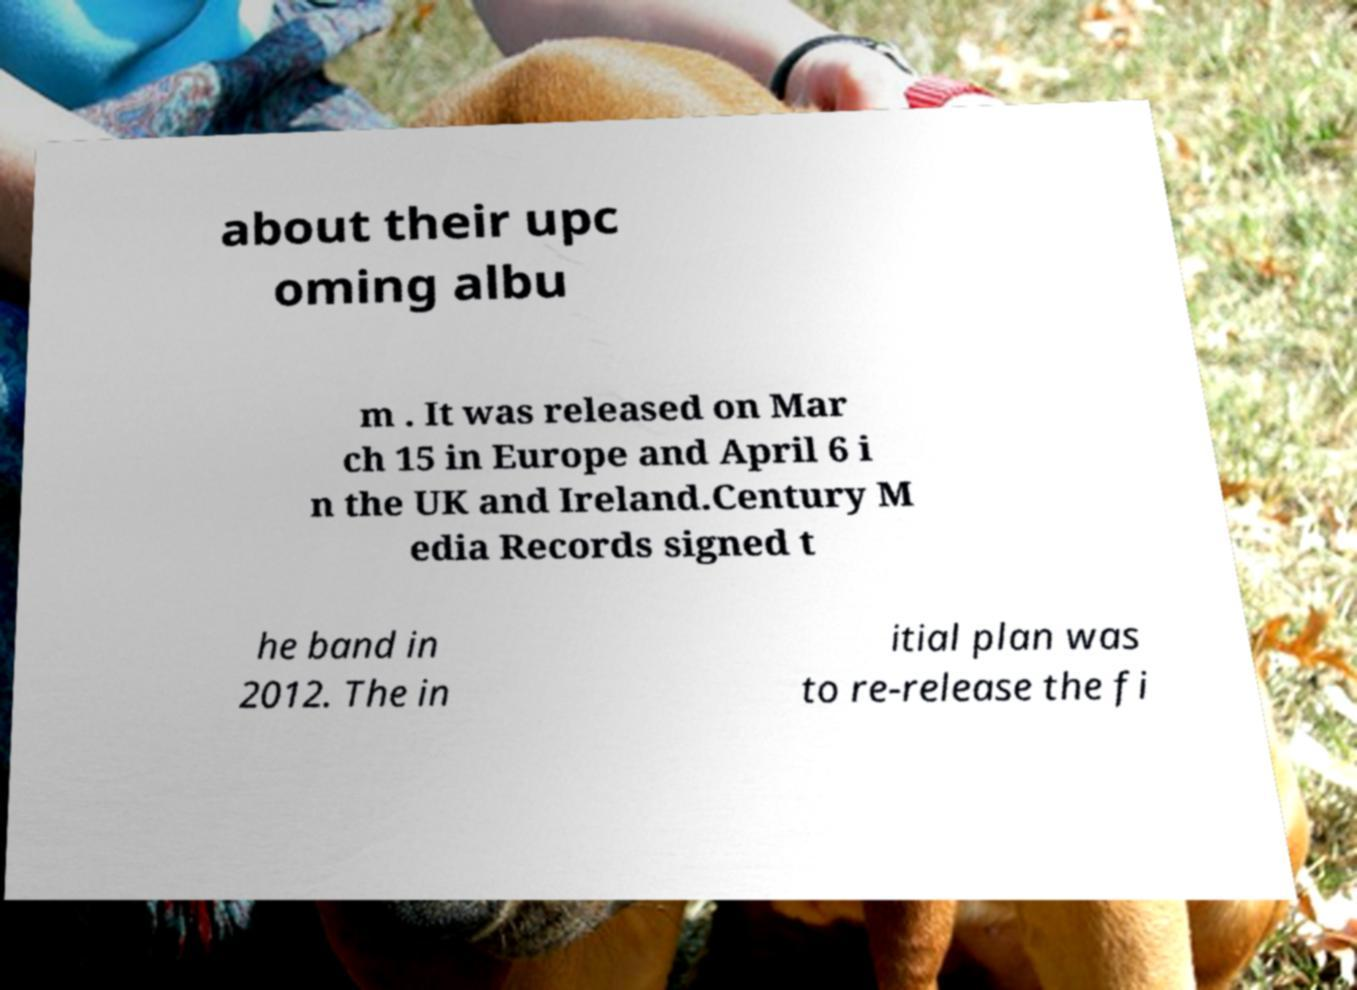There's text embedded in this image that I need extracted. Can you transcribe it verbatim? about their upc oming albu m . It was released on Mar ch 15 in Europe and April 6 i n the UK and Ireland.Century M edia Records signed t he band in 2012. The in itial plan was to re-release the fi 